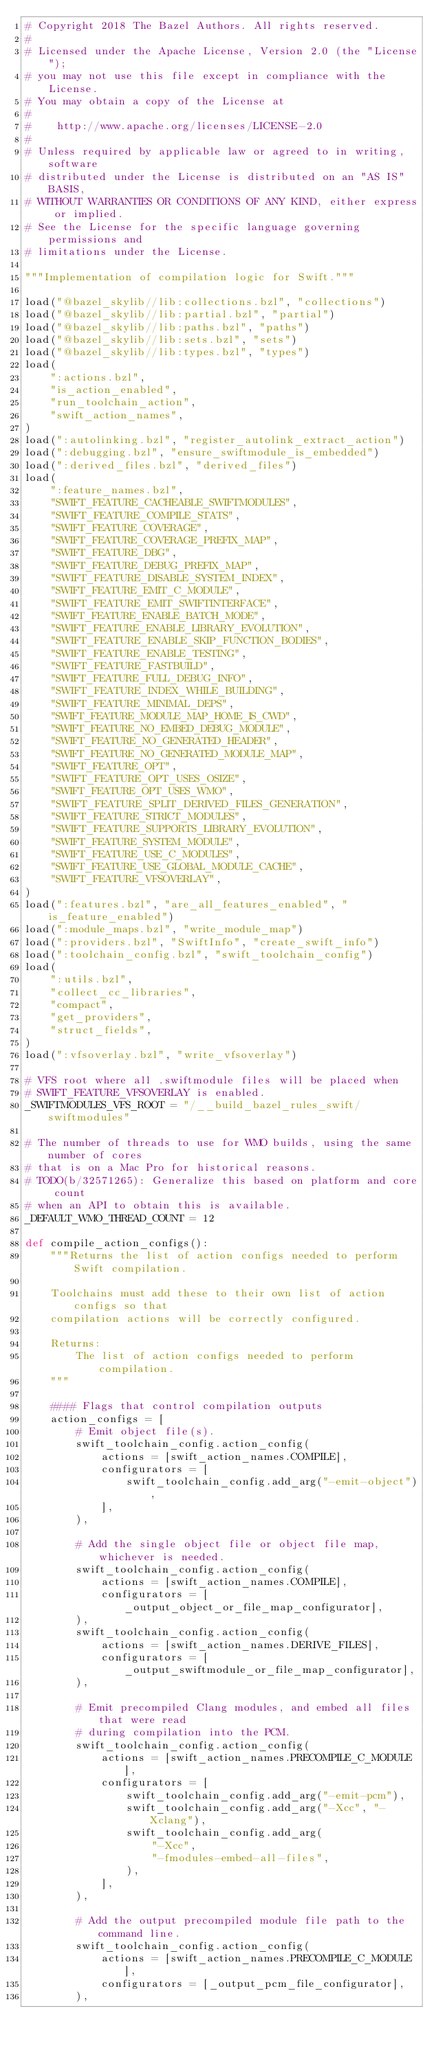<code> <loc_0><loc_0><loc_500><loc_500><_Python_># Copyright 2018 The Bazel Authors. All rights reserved.
#
# Licensed under the Apache License, Version 2.0 (the "License");
# you may not use this file except in compliance with the License.
# You may obtain a copy of the License at
#
#    http://www.apache.org/licenses/LICENSE-2.0
#
# Unless required by applicable law or agreed to in writing, software
# distributed under the License is distributed on an "AS IS" BASIS,
# WITHOUT WARRANTIES OR CONDITIONS OF ANY KIND, either express or implied.
# See the License for the specific language governing permissions and
# limitations under the License.

"""Implementation of compilation logic for Swift."""

load("@bazel_skylib//lib:collections.bzl", "collections")
load("@bazel_skylib//lib:partial.bzl", "partial")
load("@bazel_skylib//lib:paths.bzl", "paths")
load("@bazel_skylib//lib:sets.bzl", "sets")
load("@bazel_skylib//lib:types.bzl", "types")
load(
    ":actions.bzl",
    "is_action_enabled",
    "run_toolchain_action",
    "swift_action_names",
)
load(":autolinking.bzl", "register_autolink_extract_action")
load(":debugging.bzl", "ensure_swiftmodule_is_embedded")
load(":derived_files.bzl", "derived_files")
load(
    ":feature_names.bzl",
    "SWIFT_FEATURE_CACHEABLE_SWIFTMODULES",
    "SWIFT_FEATURE_COMPILE_STATS",
    "SWIFT_FEATURE_COVERAGE",
    "SWIFT_FEATURE_COVERAGE_PREFIX_MAP",
    "SWIFT_FEATURE_DBG",
    "SWIFT_FEATURE_DEBUG_PREFIX_MAP",
    "SWIFT_FEATURE_DISABLE_SYSTEM_INDEX",
    "SWIFT_FEATURE_EMIT_C_MODULE",
    "SWIFT_FEATURE_EMIT_SWIFTINTERFACE",
    "SWIFT_FEATURE_ENABLE_BATCH_MODE",
    "SWIFT_FEATURE_ENABLE_LIBRARY_EVOLUTION",
    "SWIFT_FEATURE_ENABLE_SKIP_FUNCTION_BODIES",
    "SWIFT_FEATURE_ENABLE_TESTING",
    "SWIFT_FEATURE_FASTBUILD",
    "SWIFT_FEATURE_FULL_DEBUG_INFO",
    "SWIFT_FEATURE_INDEX_WHILE_BUILDING",
    "SWIFT_FEATURE_MINIMAL_DEPS",
    "SWIFT_FEATURE_MODULE_MAP_HOME_IS_CWD",
    "SWIFT_FEATURE_NO_EMBED_DEBUG_MODULE",
    "SWIFT_FEATURE_NO_GENERATED_HEADER",
    "SWIFT_FEATURE_NO_GENERATED_MODULE_MAP",
    "SWIFT_FEATURE_OPT",
    "SWIFT_FEATURE_OPT_USES_OSIZE",
    "SWIFT_FEATURE_OPT_USES_WMO",
    "SWIFT_FEATURE_SPLIT_DERIVED_FILES_GENERATION",
    "SWIFT_FEATURE_STRICT_MODULES",
    "SWIFT_FEATURE_SUPPORTS_LIBRARY_EVOLUTION",
    "SWIFT_FEATURE_SYSTEM_MODULE",
    "SWIFT_FEATURE_USE_C_MODULES",
    "SWIFT_FEATURE_USE_GLOBAL_MODULE_CACHE",
    "SWIFT_FEATURE_VFSOVERLAY",
)
load(":features.bzl", "are_all_features_enabled", "is_feature_enabled")
load(":module_maps.bzl", "write_module_map")
load(":providers.bzl", "SwiftInfo", "create_swift_info")
load(":toolchain_config.bzl", "swift_toolchain_config")
load(
    ":utils.bzl",
    "collect_cc_libraries",
    "compact",
    "get_providers",
    "struct_fields",
)
load(":vfsoverlay.bzl", "write_vfsoverlay")

# VFS root where all .swiftmodule files will be placed when
# SWIFT_FEATURE_VFSOVERLAY is enabled.
_SWIFTMODULES_VFS_ROOT = "/__build_bazel_rules_swift/swiftmodules"

# The number of threads to use for WMO builds, using the same number of cores
# that is on a Mac Pro for historical reasons.
# TODO(b/32571265): Generalize this based on platform and core count
# when an API to obtain this is available.
_DEFAULT_WMO_THREAD_COUNT = 12

def compile_action_configs():
    """Returns the list of action configs needed to perform Swift compilation.

    Toolchains must add these to their own list of action configs so that
    compilation actions will be correctly configured.

    Returns:
        The list of action configs needed to perform compilation.
    """

    #### Flags that control compilation outputs
    action_configs = [
        # Emit object file(s).
        swift_toolchain_config.action_config(
            actions = [swift_action_names.COMPILE],
            configurators = [
                swift_toolchain_config.add_arg("-emit-object"),
            ],
        ),

        # Add the single object file or object file map, whichever is needed.
        swift_toolchain_config.action_config(
            actions = [swift_action_names.COMPILE],
            configurators = [_output_object_or_file_map_configurator],
        ),
        swift_toolchain_config.action_config(
            actions = [swift_action_names.DERIVE_FILES],
            configurators = [_output_swiftmodule_or_file_map_configurator],
        ),

        # Emit precompiled Clang modules, and embed all files that were read
        # during compilation into the PCM.
        swift_toolchain_config.action_config(
            actions = [swift_action_names.PRECOMPILE_C_MODULE],
            configurators = [
                swift_toolchain_config.add_arg("-emit-pcm"),
                swift_toolchain_config.add_arg("-Xcc", "-Xclang"),
                swift_toolchain_config.add_arg(
                    "-Xcc",
                    "-fmodules-embed-all-files",
                ),
            ],
        ),

        # Add the output precompiled module file path to the command line.
        swift_toolchain_config.action_config(
            actions = [swift_action_names.PRECOMPILE_C_MODULE],
            configurators = [_output_pcm_file_configurator],
        ),
</code> 